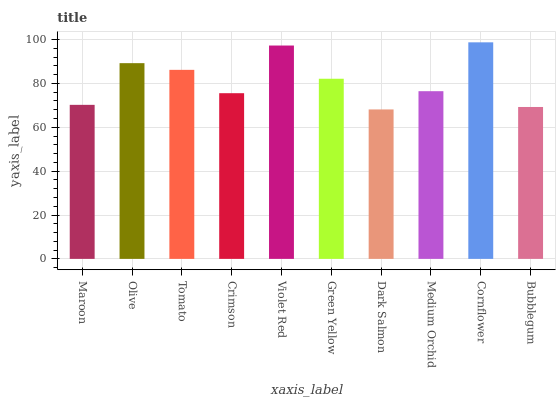Is Dark Salmon the minimum?
Answer yes or no. Yes. Is Cornflower the maximum?
Answer yes or no. Yes. Is Olive the minimum?
Answer yes or no. No. Is Olive the maximum?
Answer yes or no. No. Is Olive greater than Maroon?
Answer yes or no. Yes. Is Maroon less than Olive?
Answer yes or no. Yes. Is Maroon greater than Olive?
Answer yes or no. No. Is Olive less than Maroon?
Answer yes or no. No. Is Green Yellow the high median?
Answer yes or no. Yes. Is Medium Orchid the low median?
Answer yes or no. Yes. Is Violet Red the high median?
Answer yes or no. No. Is Bubblegum the low median?
Answer yes or no. No. 